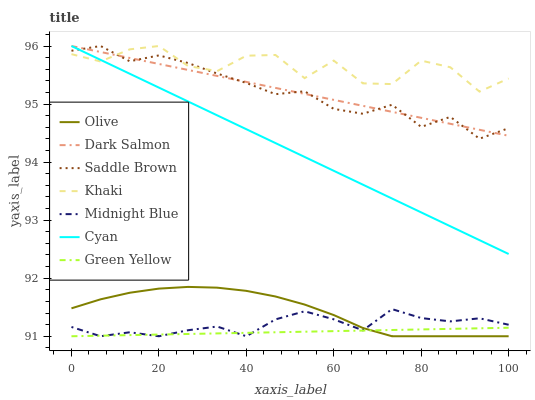Does Green Yellow have the minimum area under the curve?
Answer yes or no. Yes. Does Khaki have the maximum area under the curve?
Answer yes or no. Yes. Does Midnight Blue have the minimum area under the curve?
Answer yes or no. No. Does Midnight Blue have the maximum area under the curve?
Answer yes or no. No. Is Dark Salmon the smoothest?
Answer yes or no. Yes. Is Khaki the roughest?
Answer yes or no. Yes. Is Midnight Blue the smoothest?
Answer yes or no. No. Is Midnight Blue the roughest?
Answer yes or no. No. Does Dark Salmon have the lowest value?
Answer yes or no. No. Does Saddle Brown have the highest value?
Answer yes or no. Yes. Does Midnight Blue have the highest value?
Answer yes or no. No. Is Olive less than Khaki?
Answer yes or no. Yes. Is Cyan greater than Midnight Blue?
Answer yes or no. Yes. Does Dark Salmon intersect Saddle Brown?
Answer yes or no. Yes. Is Dark Salmon less than Saddle Brown?
Answer yes or no. No. Is Dark Salmon greater than Saddle Brown?
Answer yes or no. No. Does Olive intersect Khaki?
Answer yes or no. No. 